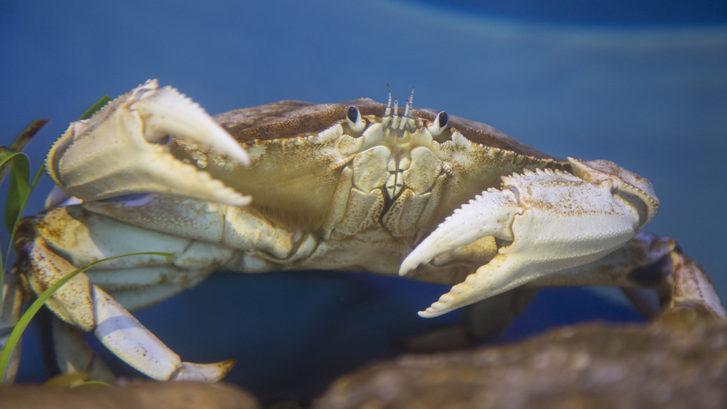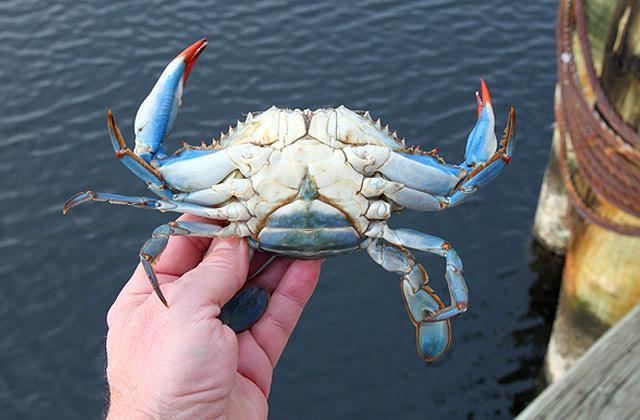The first image is the image on the left, the second image is the image on the right. Assess this claim about the two images: "A crab is being held vertically.". Correct or not? Answer yes or no. Yes. The first image is the image on the left, the second image is the image on the right. Assess this claim about the two images: "An image shows one bare hand with the thumb on the right holding up a belly-first, head-up crab, with water in the background.". Correct or not? Answer yes or no. Yes. 